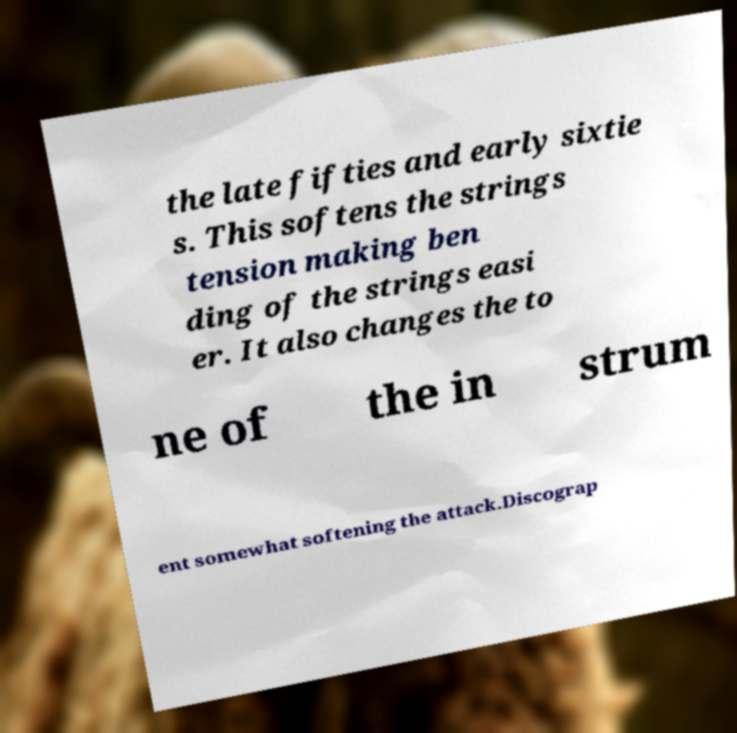Please identify and transcribe the text found in this image. the late fifties and early sixtie s. This softens the strings tension making ben ding of the strings easi er. It also changes the to ne of the in strum ent somewhat softening the attack.Discograp 